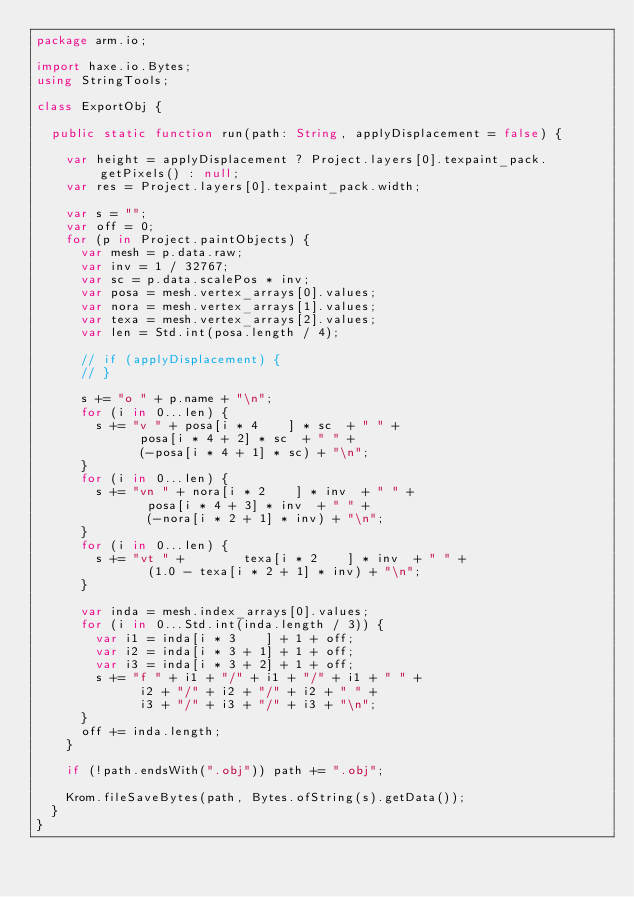<code> <loc_0><loc_0><loc_500><loc_500><_Haxe_>package arm.io;

import haxe.io.Bytes;
using StringTools;

class ExportObj {

	public static function run(path: String, applyDisplacement = false) {

		var height = applyDisplacement ? Project.layers[0].texpaint_pack.getPixels() : null;
		var res = Project.layers[0].texpaint_pack.width;

		var s = "";
		var off = 0;
		for (p in Project.paintObjects) {
			var mesh = p.data.raw;
			var inv = 1 / 32767;
			var sc = p.data.scalePos * inv;
			var posa = mesh.vertex_arrays[0].values;
			var nora = mesh.vertex_arrays[1].values;
			var texa = mesh.vertex_arrays[2].values;
			var len = Std.int(posa.length / 4);

			// if (applyDisplacement) {
			// }

			s += "o " + p.name + "\n";
			for (i in 0...len) {
				s += "v " + posa[i * 4    ] * sc  + " " +
							posa[i * 4 + 2] * sc  + " " +
						  (-posa[i * 4 + 1] * sc) + "\n";
			}
			for (i in 0...len) {
				s += "vn " + nora[i * 2    ] * inv  + " " +
							 posa[i * 4 + 3] * inv  + " " +
						   (-nora[i * 2 + 1] * inv) + "\n";
			}
			for (i in 0...len) {
				s += "vt " +        texa[i * 2    ] * inv  + " " +
							 (1.0 - texa[i * 2 + 1] * inv) + "\n";
			}

			var inda = mesh.index_arrays[0].values;
			for (i in 0...Std.int(inda.length / 3)) {
				var i1 = inda[i * 3    ] + 1 + off;
				var i2 = inda[i * 3 + 1] + 1 + off;
				var i3 = inda[i * 3 + 2] + 1 + off;
				s += "f " + i1 + "/" + i1 + "/" + i1 + " " +
							i2 + "/" + i2 + "/" + i2 + " " +
							i3 + "/" + i3 + "/" + i3 + "\n";
			}
			off += inda.length;
		}

		if (!path.endsWith(".obj")) path += ".obj";

		Krom.fileSaveBytes(path, Bytes.ofString(s).getData());
	}
}
</code> 